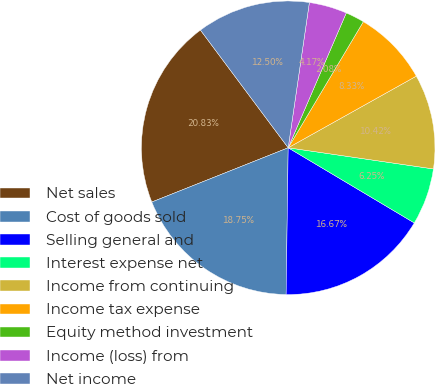Convert chart to OTSL. <chart><loc_0><loc_0><loc_500><loc_500><pie_chart><fcel>Net sales<fcel>Cost of goods sold<fcel>Selling general and<fcel>Interest expense net<fcel>Income from continuing<fcel>Income tax expense<fcel>Equity method investment<fcel>Income (loss) from<fcel>Net income<nl><fcel>20.83%<fcel>18.75%<fcel>16.67%<fcel>6.25%<fcel>10.42%<fcel>8.33%<fcel>2.08%<fcel>4.17%<fcel>12.5%<nl></chart> 